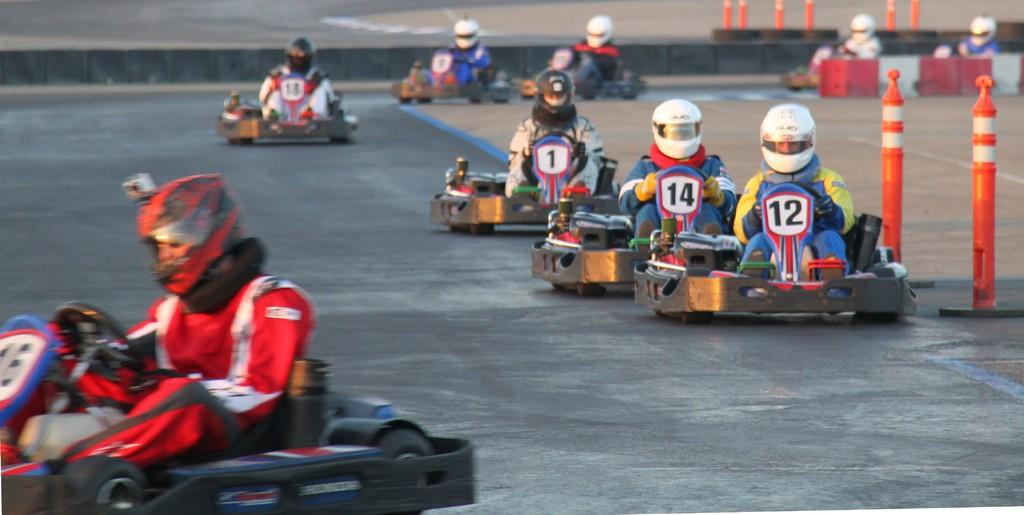What are the persons in the image doing? The persons in the image are riding go-karts. What safety precaution are the persons taking? The persons are wearing helmets. What objects can be seen on the right side of the image? There are poles and boxes on the right side of the image. What can be seen in the background of the image? There is a road visible in the background of the image. What type of chess piece is located on the slope in the image? There is no chess piece or slope present in the image. What emotion can be seen on the faces of the persons in the image due to their fear of the slope? There is no fear or slope present in the image, and the faces of the persons cannot be seen clearly enough to determine their emotions. 